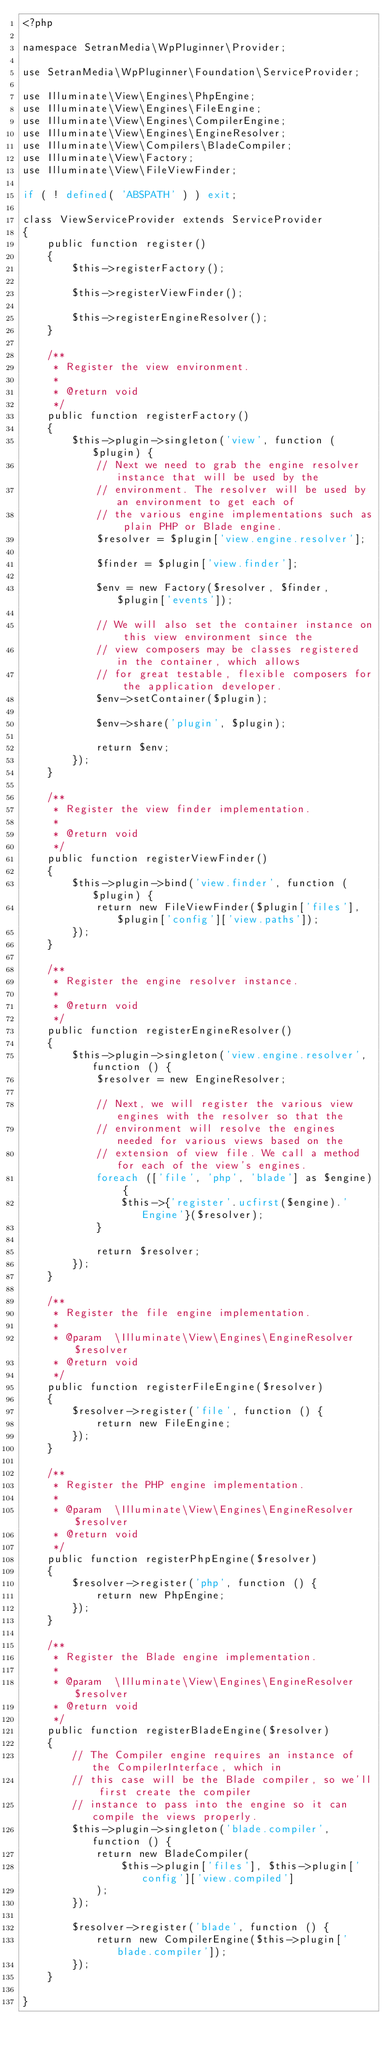Convert code to text. <code><loc_0><loc_0><loc_500><loc_500><_PHP_><?php

namespace SetranMedia\WpPluginner\Provider;

use SetranMedia\WpPluginner\Foundation\ServiceProvider;

use Illuminate\View\Engines\PhpEngine;
use Illuminate\View\Engines\FileEngine;
use Illuminate\View\Engines\CompilerEngine;
use Illuminate\View\Engines\EngineResolver;
use Illuminate\View\Compilers\BladeCompiler;
use Illuminate\View\Factory;
use Illuminate\View\FileViewFinder;

if ( ! defined( 'ABSPATH' ) ) exit;

class ViewServiceProvider extends ServiceProvider
{
    public function register()
    {
        $this->registerFactory();

        $this->registerViewFinder();

        $this->registerEngineResolver();
    }

    /**
     * Register the view environment.
     *
     * @return void
     */
    public function registerFactory()
    {
        $this->plugin->singleton('view', function ($plugin) {
            // Next we need to grab the engine resolver instance that will be used by the
            // environment. The resolver will be used by an environment to get each of
            // the various engine implementations such as plain PHP or Blade engine.
            $resolver = $plugin['view.engine.resolver'];

            $finder = $plugin['view.finder'];

            $env = new Factory($resolver, $finder, $plugin['events']);

            // We will also set the container instance on this view environment since the
            // view composers may be classes registered in the container, which allows
            // for great testable, flexible composers for the application developer.
            $env->setContainer($plugin);

            $env->share('plugin', $plugin);

            return $env;
        });
    }

    /**
     * Register the view finder implementation.
     *
     * @return void
     */
    public function registerViewFinder()
    {
        $this->plugin->bind('view.finder', function ($plugin) {
            return new FileViewFinder($plugin['files'], $plugin['config']['view.paths']);
        });
    }

    /**
     * Register the engine resolver instance.
     *
     * @return void
     */
    public function registerEngineResolver()
    {
        $this->plugin->singleton('view.engine.resolver', function () {
            $resolver = new EngineResolver;

            // Next, we will register the various view engines with the resolver so that the
            // environment will resolve the engines needed for various views based on the
            // extension of view file. We call a method for each of the view's engines.
            foreach (['file', 'php', 'blade'] as $engine) {
                $this->{'register'.ucfirst($engine).'Engine'}($resolver);
            }

            return $resolver;
        });
    }

    /**
     * Register the file engine implementation.
     *
     * @param  \Illuminate\View\Engines\EngineResolver  $resolver
     * @return void
     */
    public function registerFileEngine($resolver)
    {
        $resolver->register('file', function () {
            return new FileEngine;
        });
    }

    /**
     * Register the PHP engine implementation.
     *
     * @param  \Illuminate\View\Engines\EngineResolver  $resolver
     * @return void
     */
    public function registerPhpEngine($resolver)
    {
        $resolver->register('php', function () {
            return new PhpEngine;
        });
    }

    /**
     * Register the Blade engine implementation.
     *
     * @param  \Illuminate\View\Engines\EngineResolver  $resolver
     * @return void
     */
    public function registerBladeEngine($resolver)
    {
        // The Compiler engine requires an instance of the CompilerInterface, which in
        // this case will be the Blade compiler, so we'll first create the compiler
        // instance to pass into the engine so it can compile the views properly.
        $this->plugin->singleton('blade.compiler', function () {
            return new BladeCompiler(
                $this->plugin['files'], $this->plugin['config']['view.compiled']
            );
        });

        $resolver->register('blade', function () {
            return new CompilerEngine($this->plugin['blade.compiler']);
        });
    }

}
</code> 